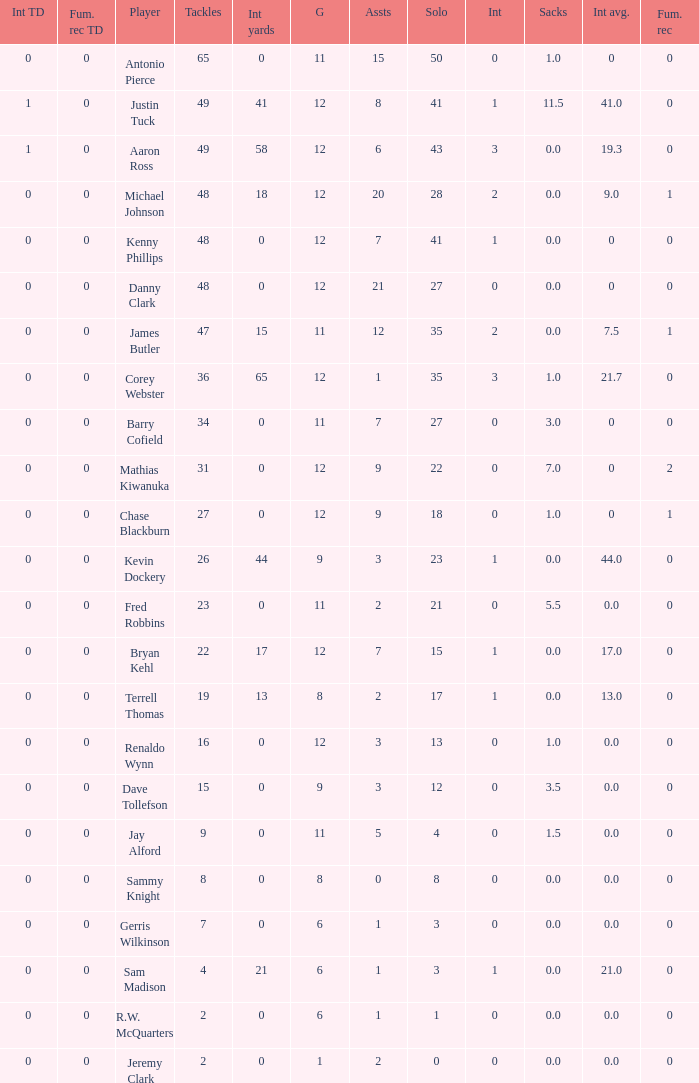Name the least int yards when sacks is 11.5 41.0. 